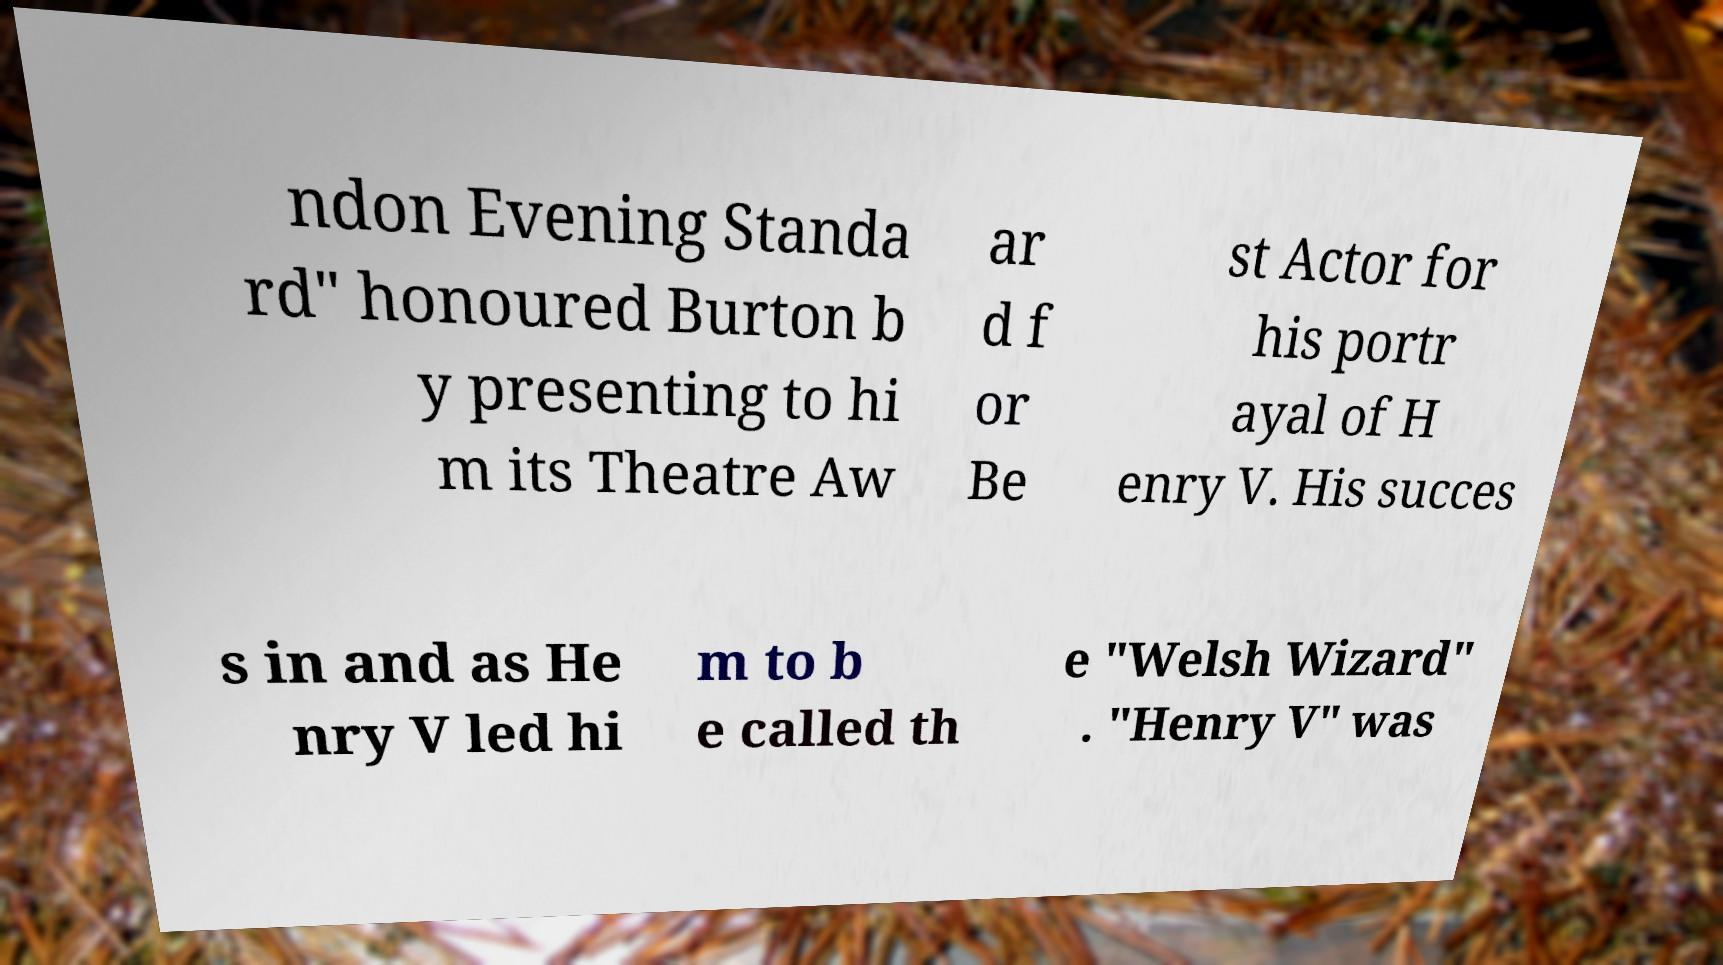There's text embedded in this image that I need extracted. Can you transcribe it verbatim? ndon Evening Standa rd" honoured Burton b y presenting to hi m its Theatre Aw ar d f or Be st Actor for his portr ayal of H enry V. His succes s in and as He nry V led hi m to b e called th e "Welsh Wizard" . "Henry V" was 